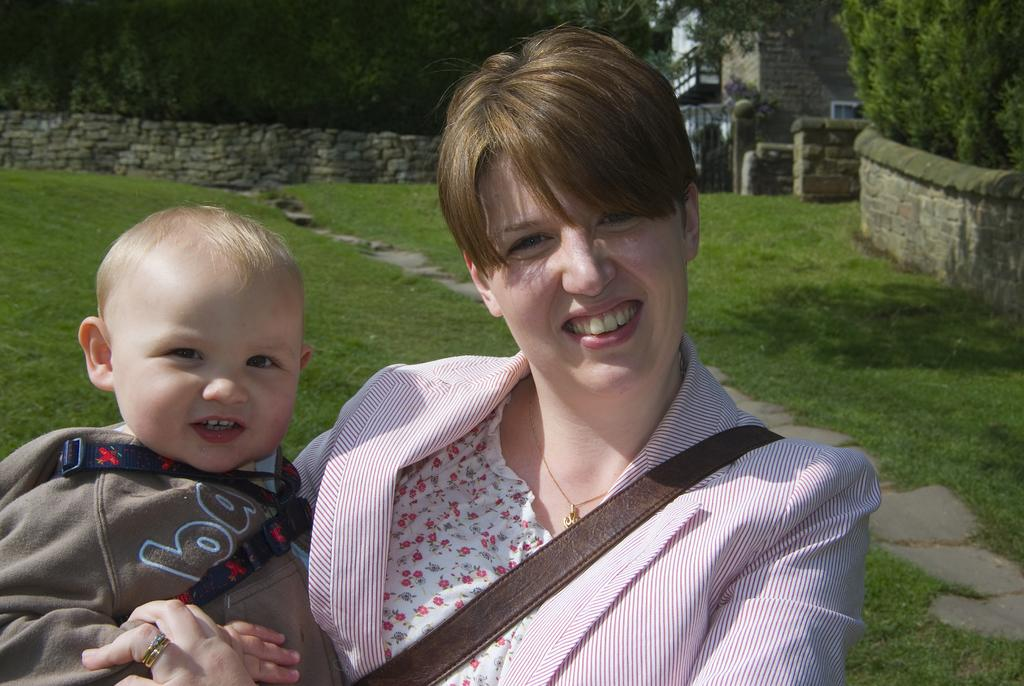Who is present in the image? There is a woman in the image. What is the woman holding? The woman is holding a baby. What can be seen in the background of the image? There is grass, trees, a wall, and a building in the background of the image. What type of metal is used to make the pizzas in the image? There are no pizzas present in the image, so it is not possible to determine what type of metal might be used to make them. 